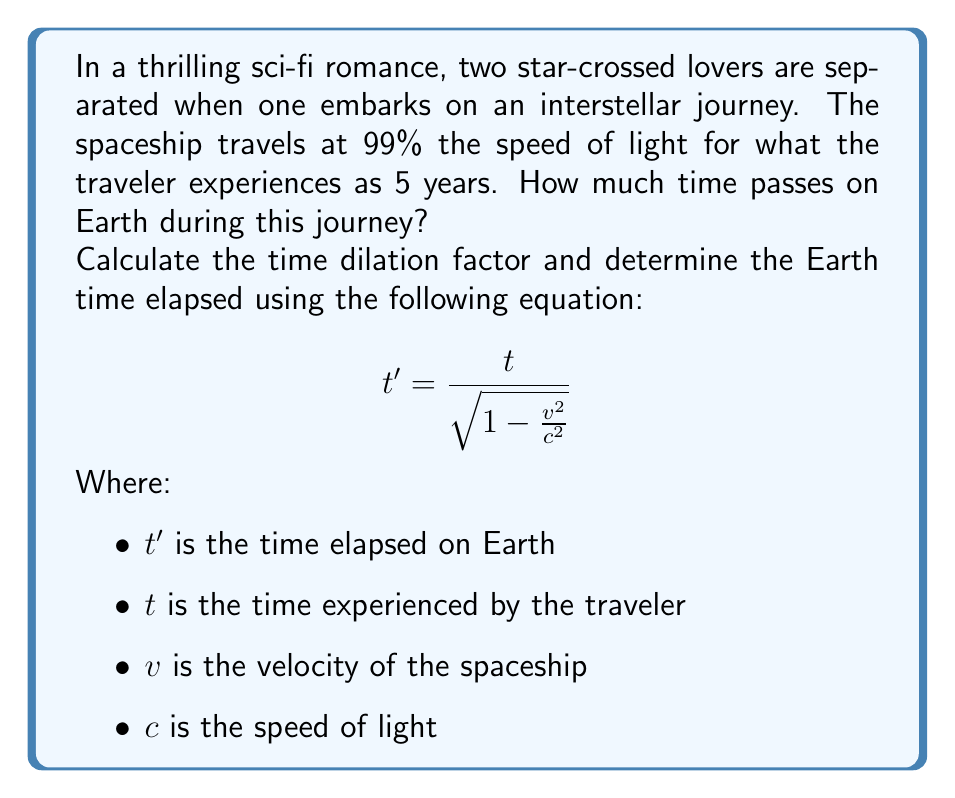Could you help me with this problem? To solve this problem, we'll follow these steps:

1. Identify the given values:
   $t = 5$ years (time experienced by the traveler)
   $v = 0.99c$ (99% of the speed of light)
   $c = 1$ (we'll use $c = 1$ for simplicity, as we're dealing with relative speeds)

2. Calculate the time dilation factor:
   $$\gamma = \frac{1}{\sqrt{1 - \frac{v^2}{c^2}}}$$
   
   Substituting the values:
   $$\gamma = \frac{1}{\sqrt{1 - \frac{(0.99)^2}{1^2}}}$$
   $$\gamma = \frac{1}{\sqrt{1 - 0.9801}}$$
   $$\gamma = \frac{1}{\sqrt{0.0199}}$$
   $$\gamma \approx 7.0888$$

3. Use the time dilation formula to calculate Earth time:
   $$t' = \gamma t$$
   $$t' = 7.0888 \times 5$$
   $$t' \approx 35.444 \text{ years}$$

Thus, while the traveler experiences 5 years on the spaceship, approximately 35.444 years will have passed on Earth.
Answer: Approximately 35.444 years will pass on Earth during the traveler's 5-year journey at 99% the speed of light. 